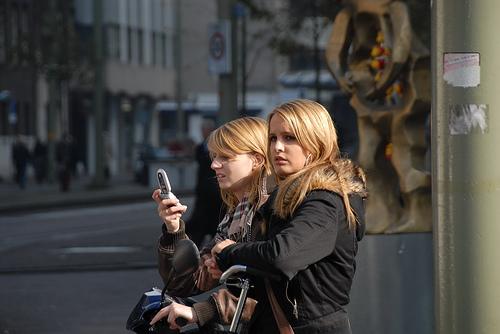Is it night time?
Answer briefly. No. Which woman is looking at her phone?
Quick response, please. Left. What color is the women's hair?
Write a very short answer. Blonde. 